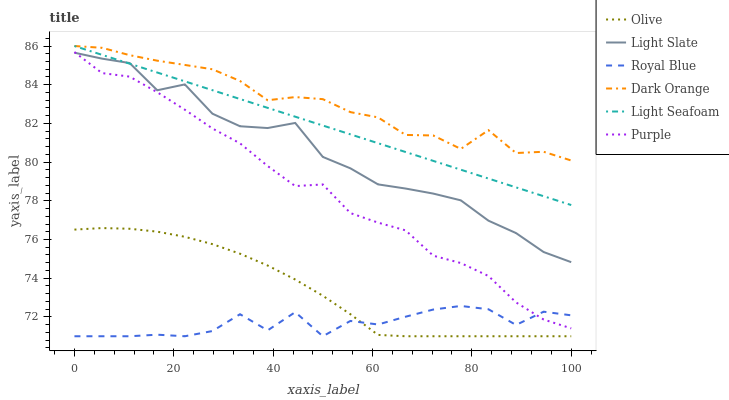Does Royal Blue have the minimum area under the curve?
Answer yes or no. Yes. Does Dark Orange have the maximum area under the curve?
Answer yes or no. Yes. Does Light Slate have the minimum area under the curve?
Answer yes or no. No. Does Light Slate have the maximum area under the curve?
Answer yes or no. No. Is Light Seafoam the smoothest?
Answer yes or no. Yes. Is Royal Blue the roughest?
Answer yes or no. Yes. Is Light Slate the smoothest?
Answer yes or no. No. Is Light Slate the roughest?
Answer yes or no. No. Does Royal Blue have the lowest value?
Answer yes or no. Yes. Does Light Slate have the lowest value?
Answer yes or no. No. Does Light Seafoam have the highest value?
Answer yes or no. Yes. Does Light Slate have the highest value?
Answer yes or no. No. Is Olive less than Purple?
Answer yes or no. Yes. Is Light Seafoam greater than Royal Blue?
Answer yes or no. Yes. Does Dark Orange intersect Light Seafoam?
Answer yes or no. Yes. Is Dark Orange less than Light Seafoam?
Answer yes or no. No. Is Dark Orange greater than Light Seafoam?
Answer yes or no. No. Does Olive intersect Purple?
Answer yes or no. No. 